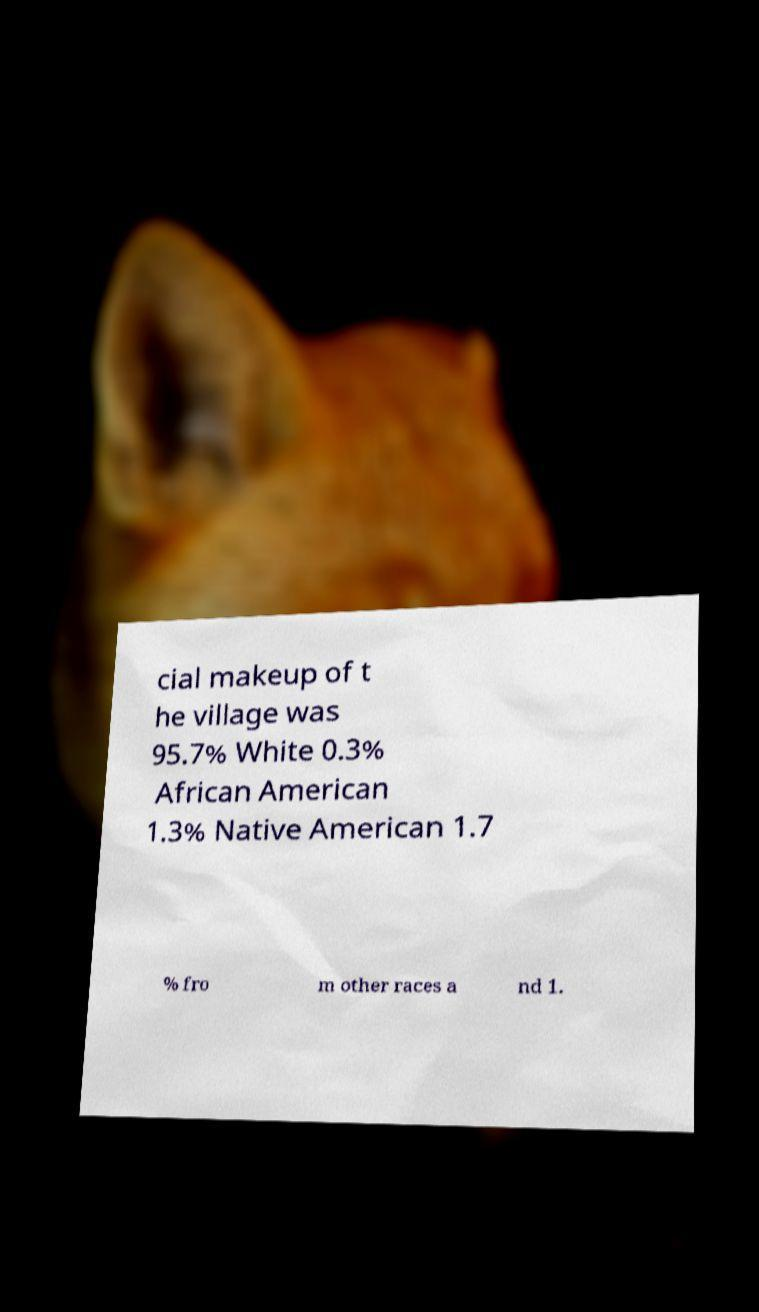Can you read and provide the text displayed in the image?This photo seems to have some interesting text. Can you extract and type it out for me? cial makeup of t he village was 95.7% White 0.3% African American 1.3% Native American 1.7 % fro m other races a nd 1. 